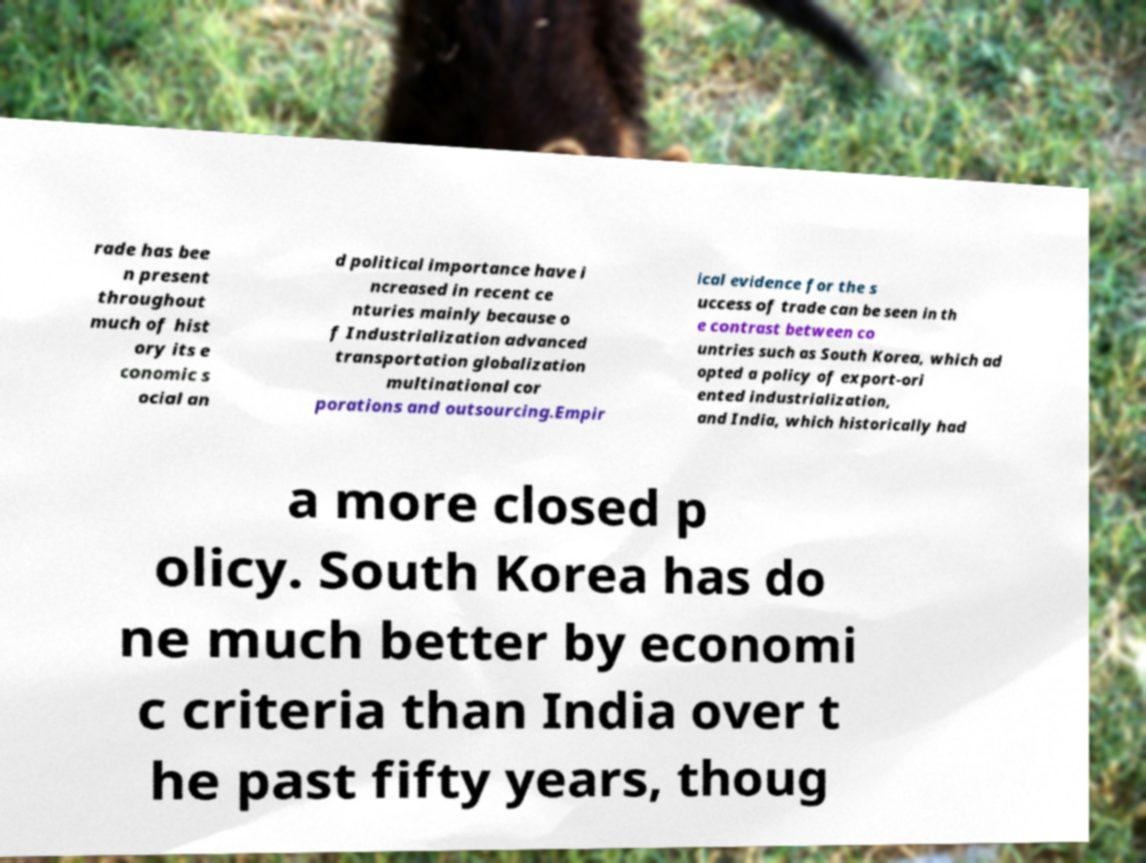Can you accurately transcribe the text from the provided image for me? rade has bee n present throughout much of hist ory its e conomic s ocial an d political importance have i ncreased in recent ce nturies mainly because o f Industrialization advanced transportation globalization multinational cor porations and outsourcing.Empir ical evidence for the s uccess of trade can be seen in th e contrast between co untries such as South Korea, which ad opted a policy of export-ori ented industrialization, and India, which historically had a more closed p olicy. South Korea has do ne much better by economi c criteria than India over t he past fifty years, thoug 